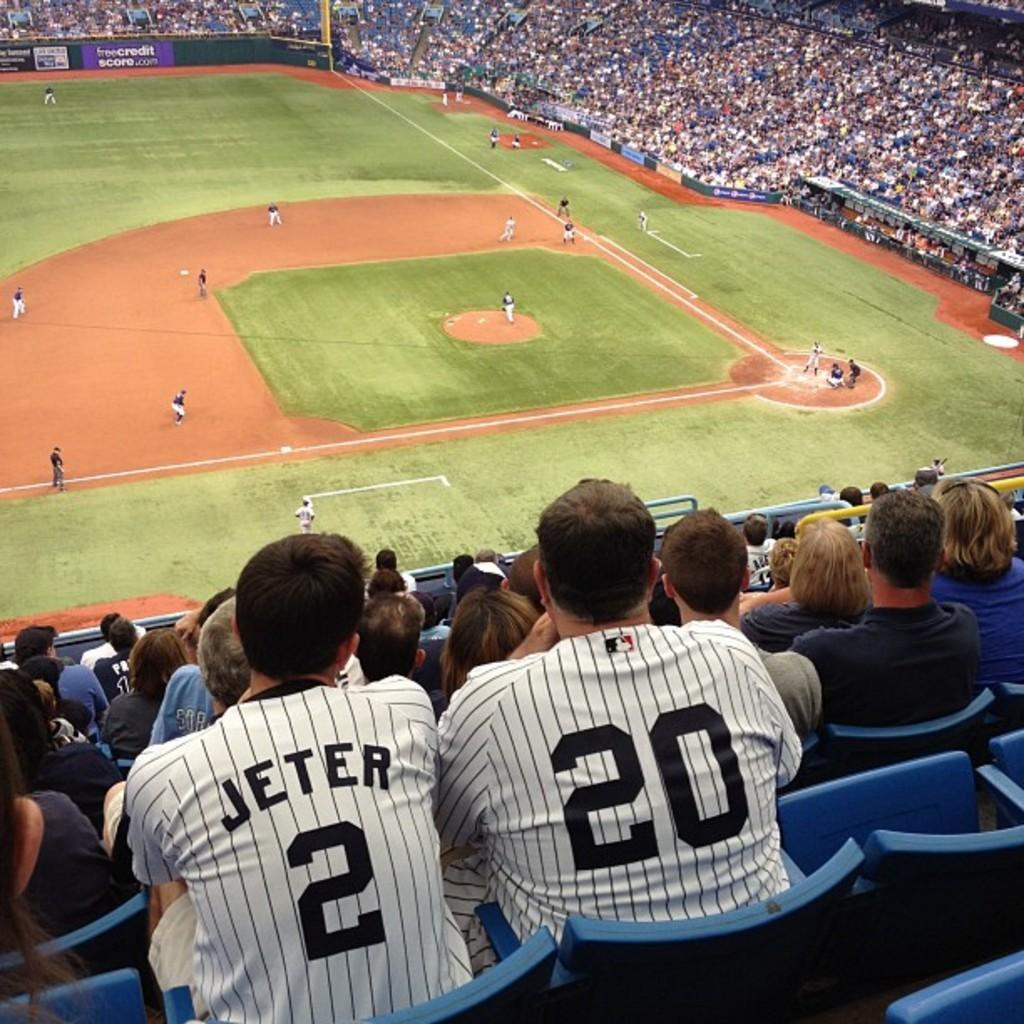<image>
Summarize the visual content of the image. Fans in a baseball stadium watch a game sponsored by freecreditscore,com 